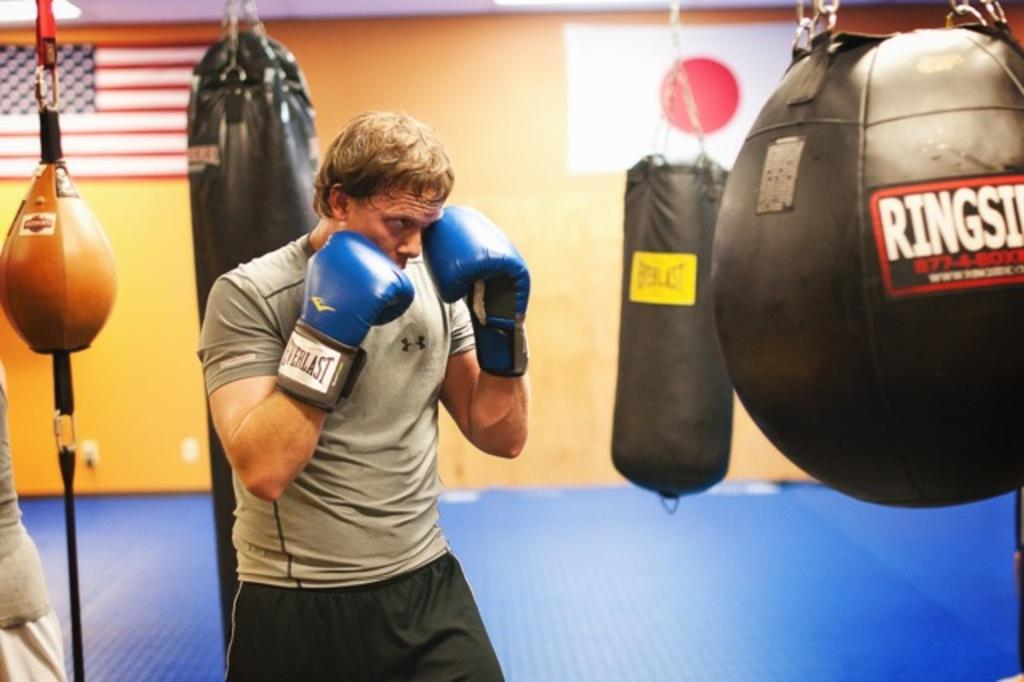<image>
Give a short and clear explanation of the subsequent image. A man with blue Everlast gloves practices in the gym. 